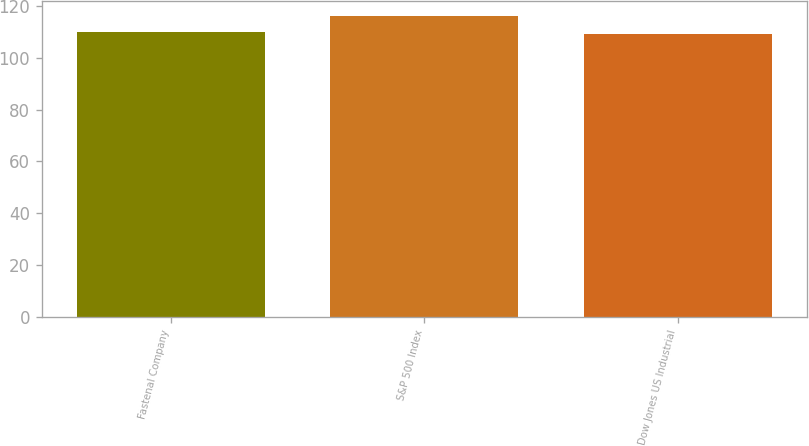Convert chart. <chart><loc_0><loc_0><loc_500><loc_500><bar_chart><fcel>Fastenal Company<fcel>S&P 500 Index<fcel>Dow Jones US Industrial<nl><fcel>110.07<fcel>116<fcel>109.05<nl></chart> 